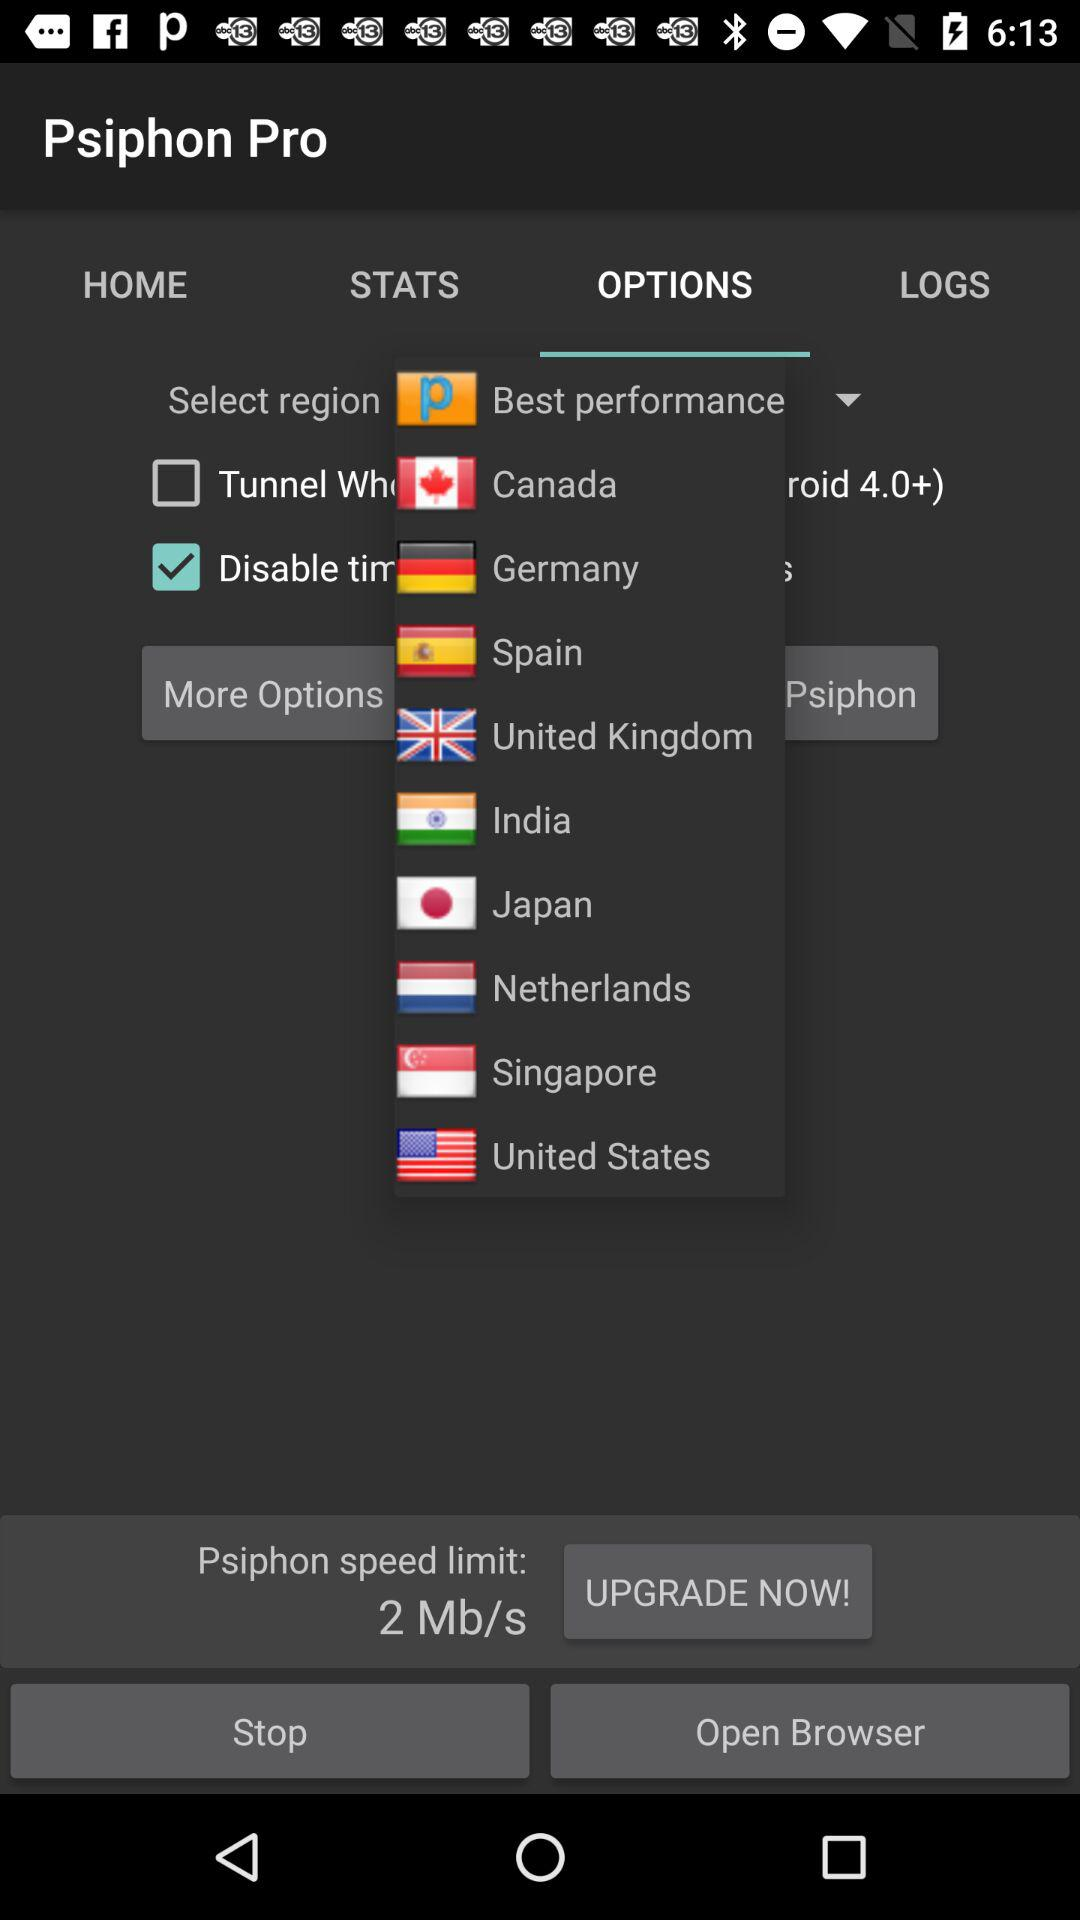What is the application name? The application name is "Psiphon Pro". 